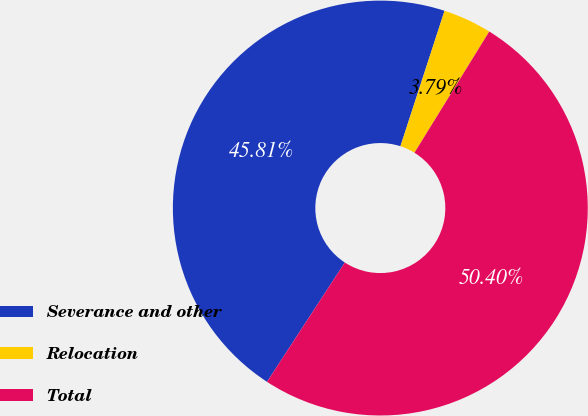Convert chart. <chart><loc_0><loc_0><loc_500><loc_500><pie_chart><fcel>Severance and other<fcel>Relocation<fcel>Total<nl><fcel>45.81%<fcel>3.79%<fcel>50.39%<nl></chart> 